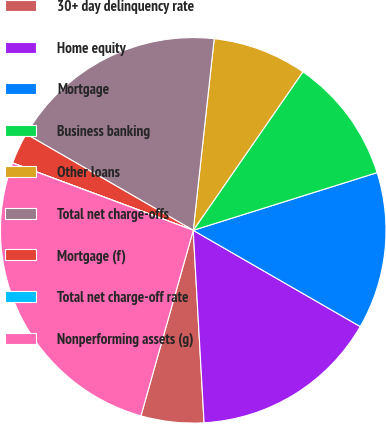<chart> <loc_0><loc_0><loc_500><loc_500><pie_chart><fcel>30+ day delinquency rate<fcel>Home equity<fcel>Mortgage<fcel>Business banking<fcel>Other loans<fcel>Total net charge-offs<fcel>Mortgage (f)<fcel>Total net charge-off rate<fcel>Nonperforming assets (g)<nl><fcel>5.27%<fcel>15.79%<fcel>13.16%<fcel>10.53%<fcel>7.9%<fcel>18.42%<fcel>2.64%<fcel>0.01%<fcel>26.31%<nl></chart> 